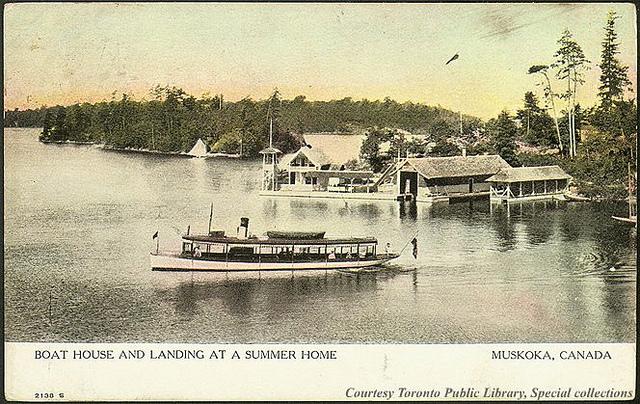Is this a painting?
Concise answer only. No. Is the water calm or rough?
Short answer required. Calm. Is there a small boat tethered to the big boat?
Write a very short answer. No. Where is this picture taken?
Write a very short answer. Muskoka, canada. 